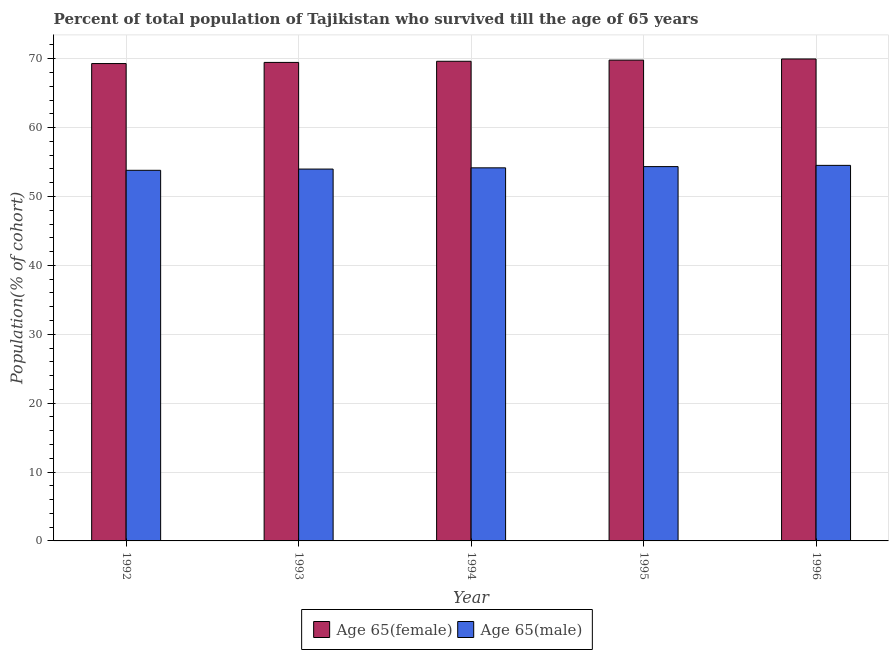How many different coloured bars are there?
Offer a terse response. 2. How many groups of bars are there?
Offer a terse response. 5. Are the number of bars per tick equal to the number of legend labels?
Offer a terse response. Yes. Are the number of bars on each tick of the X-axis equal?
Your response must be concise. Yes. In how many cases, is the number of bars for a given year not equal to the number of legend labels?
Keep it short and to the point. 0. What is the percentage of female population who survived till age of 65 in 1992?
Your answer should be very brief. 69.3. Across all years, what is the maximum percentage of male population who survived till age of 65?
Offer a terse response. 54.52. Across all years, what is the minimum percentage of male population who survived till age of 65?
Your response must be concise. 53.8. In which year was the percentage of female population who survived till age of 65 maximum?
Keep it short and to the point. 1996. In which year was the percentage of female population who survived till age of 65 minimum?
Your answer should be compact. 1992. What is the total percentage of female population who survived till age of 65 in the graph?
Provide a short and direct response. 348.15. What is the difference between the percentage of female population who survived till age of 65 in 1994 and that in 1996?
Your response must be concise. -0.33. What is the difference between the percentage of male population who survived till age of 65 in 1996 and the percentage of female population who survived till age of 65 in 1995?
Ensure brevity in your answer.  0.18. What is the average percentage of female population who survived till age of 65 per year?
Offer a very short reply. 69.63. In the year 1996, what is the difference between the percentage of male population who survived till age of 65 and percentage of female population who survived till age of 65?
Offer a terse response. 0. In how many years, is the percentage of male population who survived till age of 65 greater than 24 %?
Offer a very short reply. 5. What is the ratio of the percentage of female population who survived till age of 65 in 1995 to that in 1996?
Your answer should be compact. 1. What is the difference between the highest and the second highest percentage of female population who survived till age of 65?
Keep it short and to the point. 0.17. What is the difference between the highest and the lowest percentage of female population who survived till age of 65?
Your response must be concise. 0.67. Is the sum of the percentage of female population who survived till age of 65 in 1992 and 1995 greater than the maximum percentage of male population who survived till age of 65 across all years?
Your answer should be compact. Yes. What does the 1st bar from the left in 1996 represents?
Ensure brevity in your answer.  Age 65(female). What does the 2nd bar from the right in 1996 represents?
Your response must be concise. Age 65(female). How many bars are there?
Provide a short and direct response. 10. How many years are there in the graph?
Give a very brief answer. 5. Does the graph contain grids?
Provide a short and direct response. Yes. How are the legend labels stacked?
Offer a terse response. Horizontal. What is the title of the graph?
Keep it short and to the point. Percent of total population of Tajikistan who survived till the age of 65 years. Does "Working only" appear as one of the legend labels in the graph?
Give a very brief answer. No. What is the label or title of the X-axis?
Your answer should be compact. Year. What is the label or title of the Y-axis?
Your answer should be compact. Population(% of cohort). What is the Population(% of cohort) of Age 65(female) in 1992?
Offer a very short reply. 69.3. What is the Population(% of cohort) in Age 65(male) in 1992?
Make the answer very short. 53.8. What is the Population(% of cohort) of Age 65(female) in 1993?
Your answer should be very brief. 69.46. What is the Population(% of cohort) of Age 65(male) in 1993?
Provide a succinct answer. 53.98. What is the Population(% of cohort) in Age 65(female) in 1994?
Your response must be concise. 69.63. What is the Population(% of cohort) in Age 65(male) in 1994?
Offer a terse response. 54.16. What is the Population(% of cohort) of Age 65(female) in 1995?
Your response must be concise. 69.8. What is the Population(% of cohort) of Age 65(male) in 1995?
Offer a very short reply. 54.34. What is the Population(% of cohort) of Age 65(female) in 1996?
Provide a short and direct response. 69.96. What is the Population(% of cohort) of Age 65(male) in 1996?
Ensure brevity in your answer.  54.52. Across all years, what is the maximum Population(% of cohort) in Age 65(female)?
Make the answer very short. 69.96. Across all years, what is the maximum Population(% of cohort) in Age 65(male)?
Give a very brief answer. 54.52. Across all years, what is the minimum Population(% of cohort) of Age 65(female)?
Your response must be concise. 69.3. Across all years, what is the minimum Population(% of cohort) in Age 65(male)?
Your answer should be very brief. 53.8. What is the total Population(% of cohort) in Age 65(female) in the graph?
Make the answer very short. 348.15. What is the total Population(% of cohort) in Age 65(male) in the graph?
Keep it short and to the point. 270.79. What is the difference between the Population(% of cohort) in Age 65(female) in 1992 and that in 1993?
Keep it short and to the point. -0.17. What is the difference between the Population(% of cohort) in Age 65(male) in 1992 and that in 1993?
Provide a succinct answer. -0.18. What is the difference between the Population(% of cohort) of Age 65(female) in 1992 and that in 1994?
Your answer should be compact. -0.33. What is the difference between the Population(% of cohort) of Age 65(male) in 1992 and that in 1994?
Give a very brief answer. -0.36. What is the difference between the Population(% of cohort) in Age 65(female) in 1992 and that in 1995?
Your response must be concise. -0.5. What is the difference between the Population(% of cohort) in Age 65(male) in 1992 and that in 1995?
Provide a short and direct response. -0.54. What is the difference between the Population(% of cohort) of Age 65(female) in 1992 and that in 1996?
Keep it short and to the point. -0.67. What is the difference between the Population(% of cohort) in Age 65(male) in 1992 and that in 1996?
Provide a succinct answer. -0.72. What is the difference between the Population(% of cohort) in Age 65(female) in 1993 and that in 1994?
Provide a succinct answer. -0.17. What is the difference between the Population(% of cohort) in Age 65(male) in 1993 and that in 1994?
Provide a short and direct response. -0.18. What is the difference between the Population(% of cohort) in Age 65(female) in 1993 and that in 1995?
Offer a terse response. -0.33. What is the difference between the Population(% of cohort) of Age 65(male) in 1993 and that in 1995?
Offer a terse response. -0.36. What is the difference between the Population(% of cohort) of Age 65(female) in 1993 and that in 1996?
Your answer should be compact. -0.5. What is the difference between the Population(% of cohort) of Age 65(male) in 1993 and that in 1996?
Your response must be concise. -0.54. What is the difference between the Population(% of cohort) of Age 65(female) in 1994 and that in 1995?
Provide a short and direct response. -0.17. What is the difference between the Population(% of cohort) in Age 65(male) in 1994 and that in 1995?
Your answer should be very brief. -0.18. What is the difference between the Population(% of cohort) of Age 65(female) in 1994 and that in 1996?
Your answer should be very brief. -0.33. What is the difference between the Population(% of cohort) of Age 65(male) in 1994 and that in 1996?
Ensure brevity in your answer.  -0.36. What is the difference between the Population(% of cohort) of Age 65(female) in 1995 and that in 1996?
Ensure brevity in your answer.  -0.17. What is the difference between the Population(% of cohort) of Age 65(male) in 1995 and that in 1996?
Your answer should be very brief. -0.18. What is the difference between the Population(% of cohort) in Age 65(female) in 1992 and the Population(% of cohort) in Age 65(male) in 1993?
Offer a very short reply. 15.32. What is the difference between the Population(% of cohort) of Age 65(female) in 1992 and the Population(% of cohort) of Age 65(male) in 1994?
Keep it short and to the point. 15.14. What is the difference between the Population(% of cohort) of Age 65(female) in 1992 and the Population(% of cohort) of Age 65(male) in 1995?
Give a very brief answer. 14.96. What is the difference between the Population(% of cohort) in Age 65(female) in 1992 and the Population(% of cohort) in Age 65(male) in 1996?
Keep it short and to the point. 14.78. What is the difference between the Population(% of cohort) of Age 65(female) in 1993 and the Population(% of cohort) of Age 65(male) in 1994?
Provide a short and direct response. 15.3. What is the difference between the Population(% of cohort) of Age 65(female) in 1993 and the Population(% of cohort) of Age 65(male) in 1995?
Your answer should be very brief. 15.12. What is the difference between the Population(% of cohort) of Age 65(female) in 1993 and the Population(% of cohort) of Age 65(male) in 1996?
Give a very brief answer. 14.95. What is the difference between the Population(% of cohort) in Age 65(female) in 1994 and the Population(% of cohort) in Age 65(male) in 1995?
Your answer should be very brief. 15.29. What is the difference between the Population(% of cohort) in Age 65(female) in 1994 and the Population(% of cohort) in Age 65(male) in 1996?
Provide a short and direct response. 15.11. What is the difference between the Population(% of cohort) of Age 65(female) in 1995 and the Population(% of cohort) of Age 65(male) in 1996?
Offer a very short reply. 15.28. What is the average Population(% of cohort) in Age 65(female) per year?
Give a very brief answer. 69.63. What is the average Population(% of cohort) of Age 65(male) per year?
Provide a short and direct response. 54.16. In the year 1992, what is the difference between the Population(% of cohort) of Age 65(female) and Population(% of cohort) of Age 65(male)?
Make the answer very short. 15.5. In the year 1993, what is the difference between the Population(% of cohort) in Age 65(female) and Population(% of cohort) in Age 65(male)?
Provide a succinct answer. 15.48. In the year 1994, what is the difference between the Population(% of cohort) of Age 65(female) and Population(% of cohort) of Age 65(male)?
Ensure brevity in your answer.  15.47. In the year 1995, what is the difference between the Population(% of cohort) in Age 65(female) and Population(% of cohort) in Age 65(male)?
Offer a very short reply. 15.46. In the year 1996, what is the difference between the Population(% of cohort) in Age 65(female) and Population(% of cohort) in Age 65(male)?
Ensure brevity in your answer.  15.44. What is the ratio of the Population(% of cohort) of Age 65(female) in 1992 to that in 1994?
Ensure brevity in your answer.  1. What is the ratio of the Population(% of cohort) of Age 65(male) in 1992 to that in 1995?
Ensure brevity in your answer.  0.99. What is the ratio of the Population(% of cohort) in Age 65(male) in 1992 to that in 1996?
Your response must be concise. 0.99. What is the ratio of the Population(% of cohort) of Age 65(female) in 1993 to that in 1994?
Make the answer very short. 1. What is the ratio of the Population(% of cohort) of Age 65(male) in 1994 to that in 1995?
Offer a very short reply. 1. What is the ratio of the Population(% of cohort) of Age 65(male) in 1994 to that in 1996?
Keep it short and to the point. 0.99. What is the difference between the highest and the second highest Population(% of cohort) of Age 65(female)?
Keep it short and to the point. 0.17. What is the difference between the highest and the second highest Population(% of cohort) in Age 65(male)?
Provide a short and direct response. 0.18. What is the difference between the highest and the lowest Population(% of cohort) in Age 65(female)?
Ensure brevity in your answer.  0.67. What is the difference between the highest and the lowest Population(% of cohort) in Age 65(male)?
Provide a succinct answer. 0.72. 